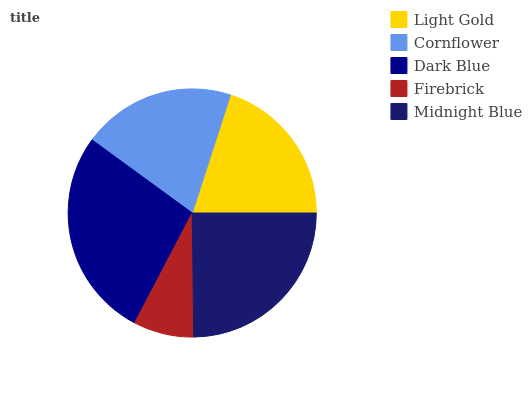Is Firebrick the minimum?
Answer yes or no. Yes. Is Dark Blue the maximum?
Answer yes or no. Yes. Is Cornflower the minimum?
Answer yes or no. No. Is Cornflower the maximum?
Answer yes or no. No. Is Light Gold greater than Cornflower?
Answer yes or no. Yes. Is Cornflower less than Light Gold?
Answer yes or no. Yes. Is Cornflower greater than Light Gold?
Answer yes or no. No. Is Light Gold less than Cornflower?
Answer yes or no. No. Is Light Gold the high median?
Answer yes or no. Yes. Is Light Gold the low median?
Answer yes or no. Yes. Is Midnight Blue the high median?
Answer yes or no. No. Is Cornflower the low median?
Answer yes or no. No. 